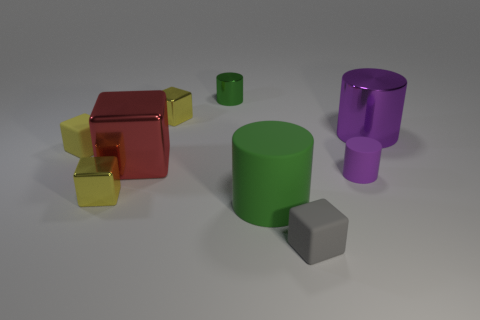Can you describe the arrangement of the colored shapes seen here? Certainly! The shapes are arranged in a somewhat scattered fashion across a flat surface. In the foreground, there is a small gray matte block sitting to the left front side of a large green matte cylinder. To the right rear, we have a tall purple cylinder and a large metallic red cube, next to which are two smaller yellow translucent cubes. The arrangement is visually interesting, emphasizing contrast between shapes, colors, and materials. 